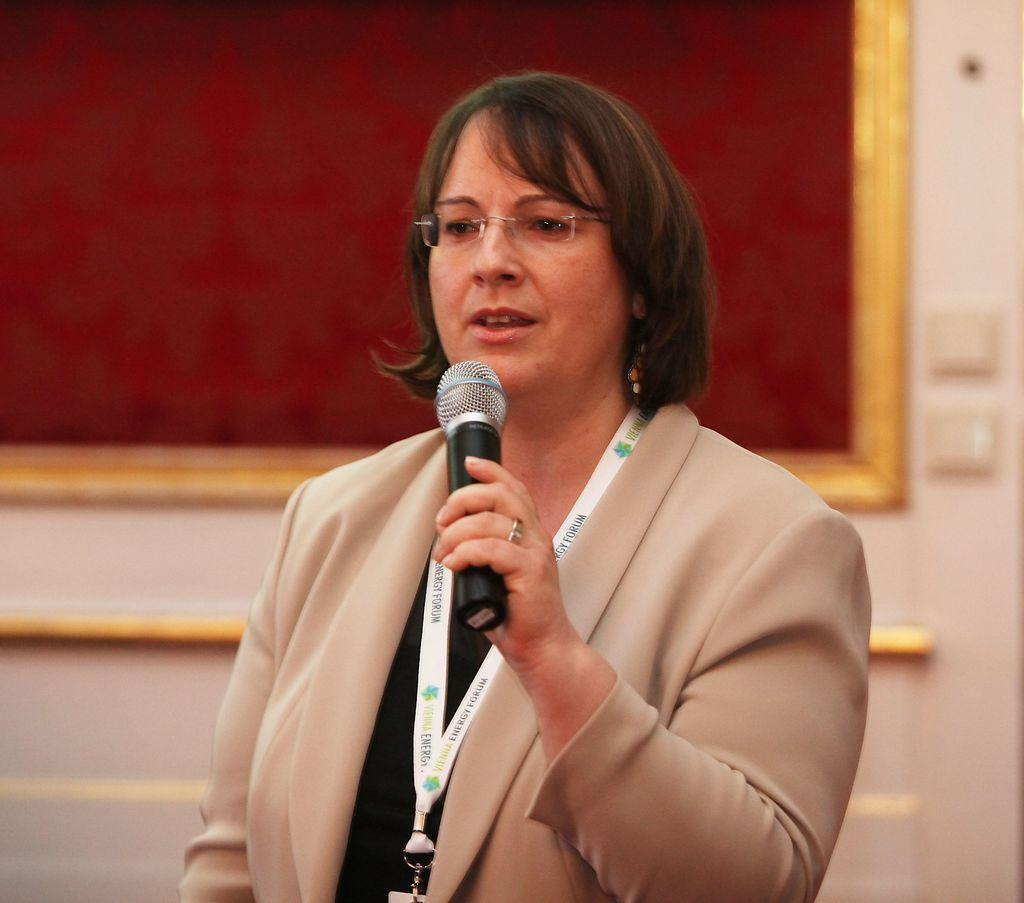What is the woman in the image doing? The woman is holding a mic in her hand and talking. What is the woman wearing in the image? The woman is wearing a blazer, an ID card, and spectacles. What can be seen in the background of the image? There is a wall and a board in the background of the image. What type of marble is visible on the floor in the image? There is no marble visible on the floor in the image. How many pins are attached to the woman's blazer in the image? There is no mention of pins on the woman's blazer in the image. 